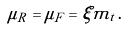Convert formula to latex. <formula><loc_0><loc_0><loc_500><loc_500>\mu _ { R } = \mu _ { F } = \xi m _ { t } \, .</formula> 